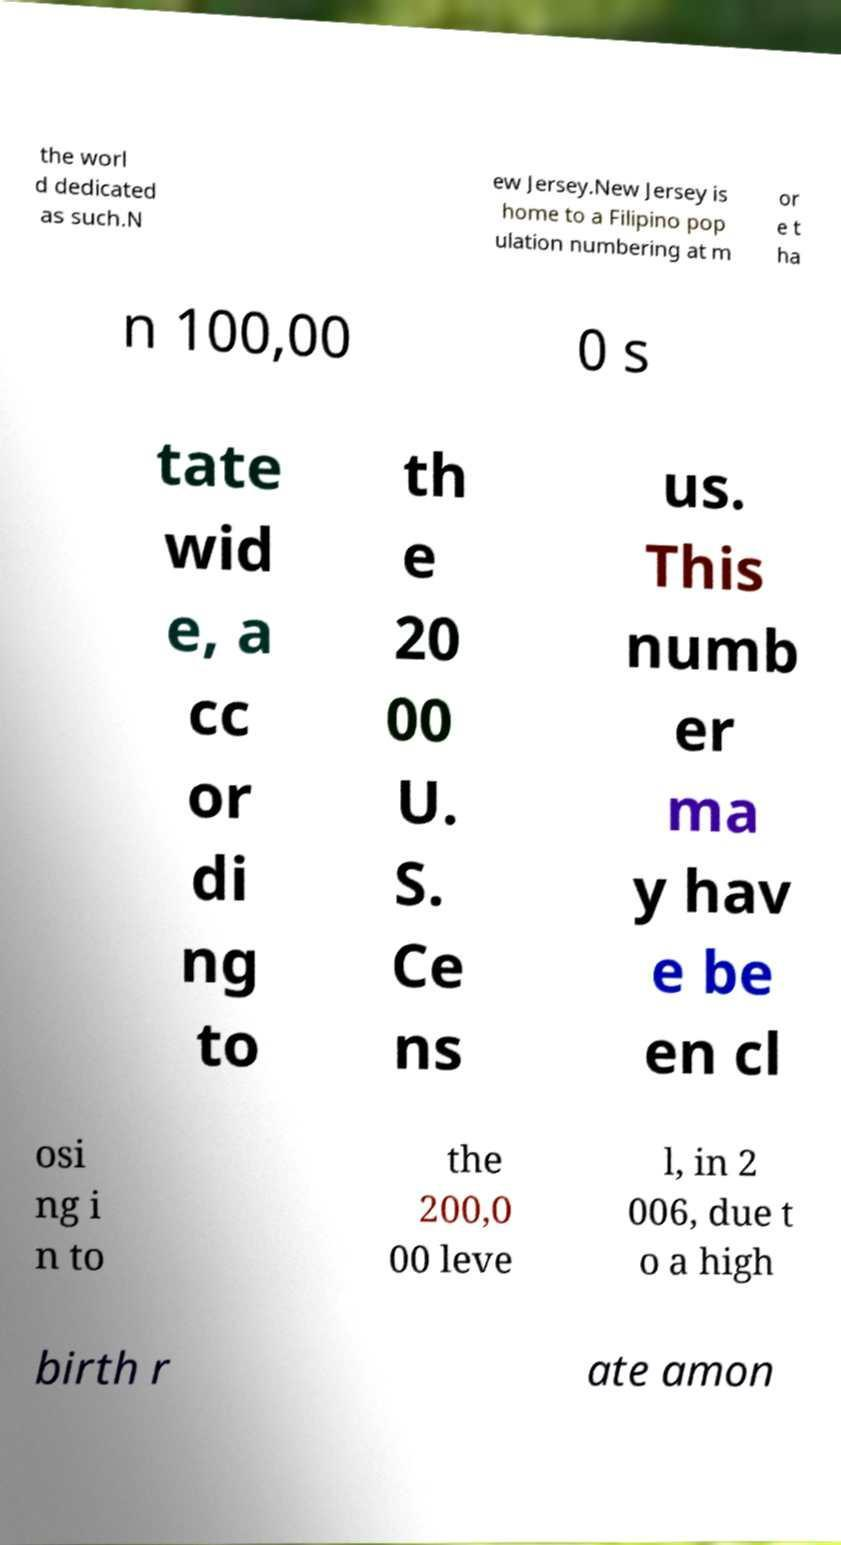Please identify and transcribe the text found in this image. the worl d dedicated as such.N ew Jersey.New Jersey is home to a Filipino pop ulation numbering at m or e t ha n 100,00 0 s tate wid e, a cc or di ng to th e 20 00 U. S. Ce ns us. This numb er ma y hav e be en cl osi ng i n to the 200,0 00 leve l, in 2 006, due t o a high birth r ate amon 